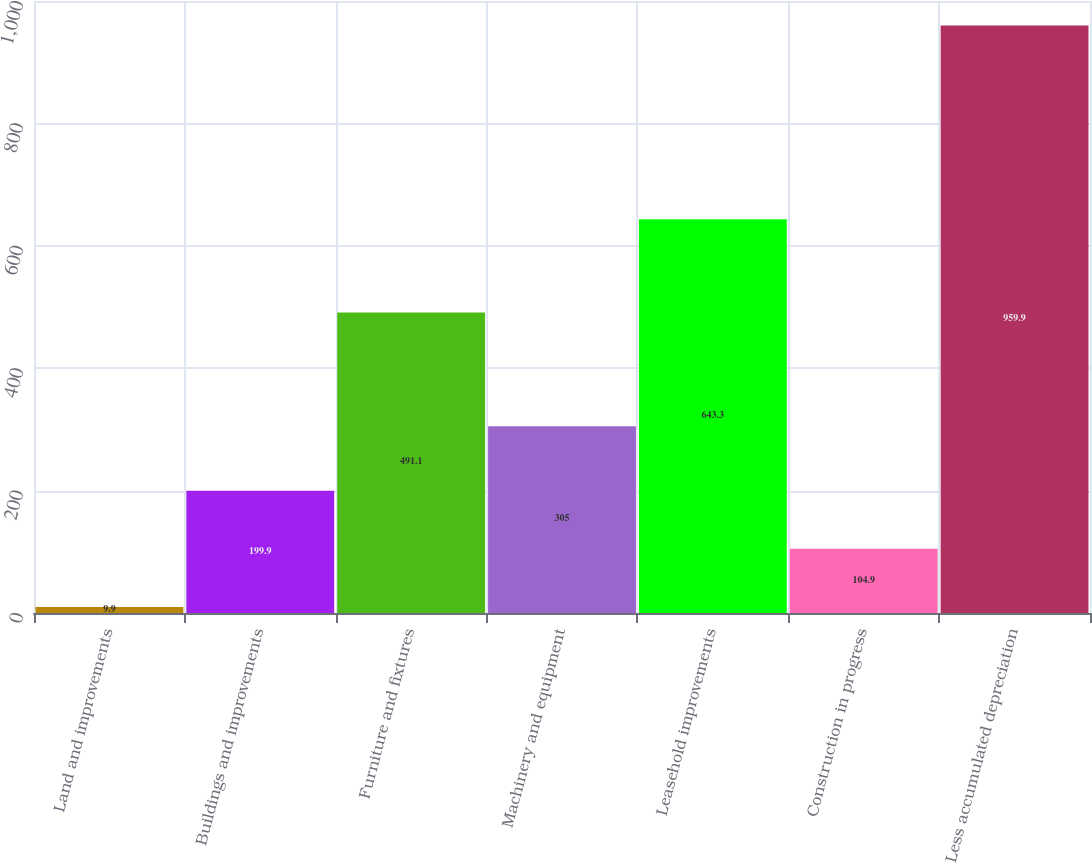Convert chart to OTSL. <chart><loc_0><loc_0><loc_500><loc_500><bar_chart><fcel>Land and improvements<fcel>Buildings and improvements<fcel>Furniture and fixtures<fcel>Machinery and equipment<fcel>Leasehold improvements<fcel>Construction in progress<fcel>Less accumulated depreciation<nl><fcel>9.9<fcel>199.9<fcel>491.1<fcel>305<fcel>643.3<fcel>104.9<fcel>959.9<nl></chart> 